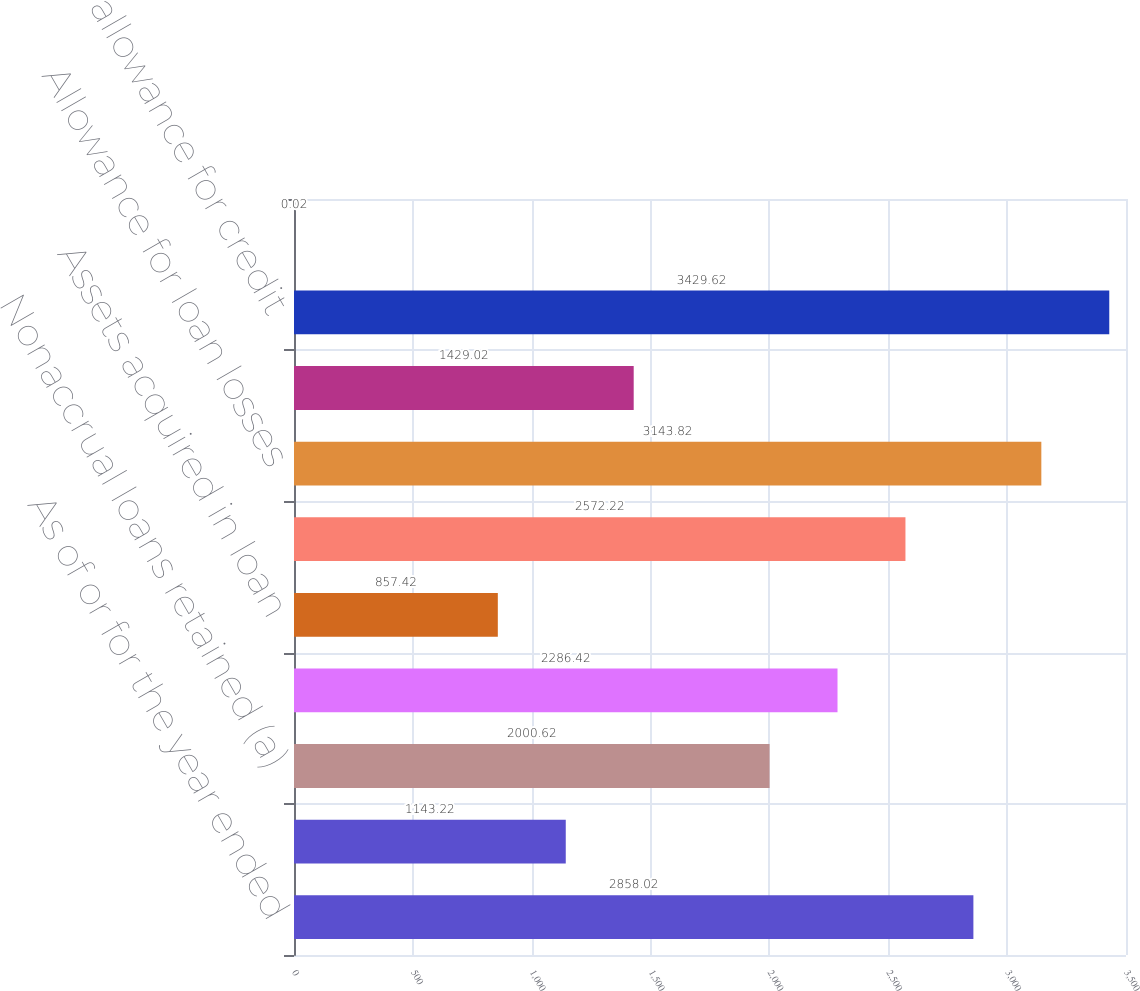Convert chart to OTSL. <chart><loc_0><loc_0><loc_500><loc_500><bar_chart><fcel>As of or for the year ended<fcel>Net charge-offs/(recoveries)<fcel>Nonaccrual loans retained (a)<fcel>Total nonaccrual loans<fcel>Assets acquired in loan<fcel>Total nonperforming assets<fcel>Allowance for loan losses<fcel>Allowance for lending-related<fcel>Total allowance for credit<fcel>Net charge-off/(recovery) rate<nl><fcel>2858.02<fcel>1143.22<fcel>2000.62<fcel>2286.42<fcel>857.42<fcel>2572.22<fcel>3143.82<fcel>1429.02<fcel>3429.62<fcel>0.02<nl></chart> 